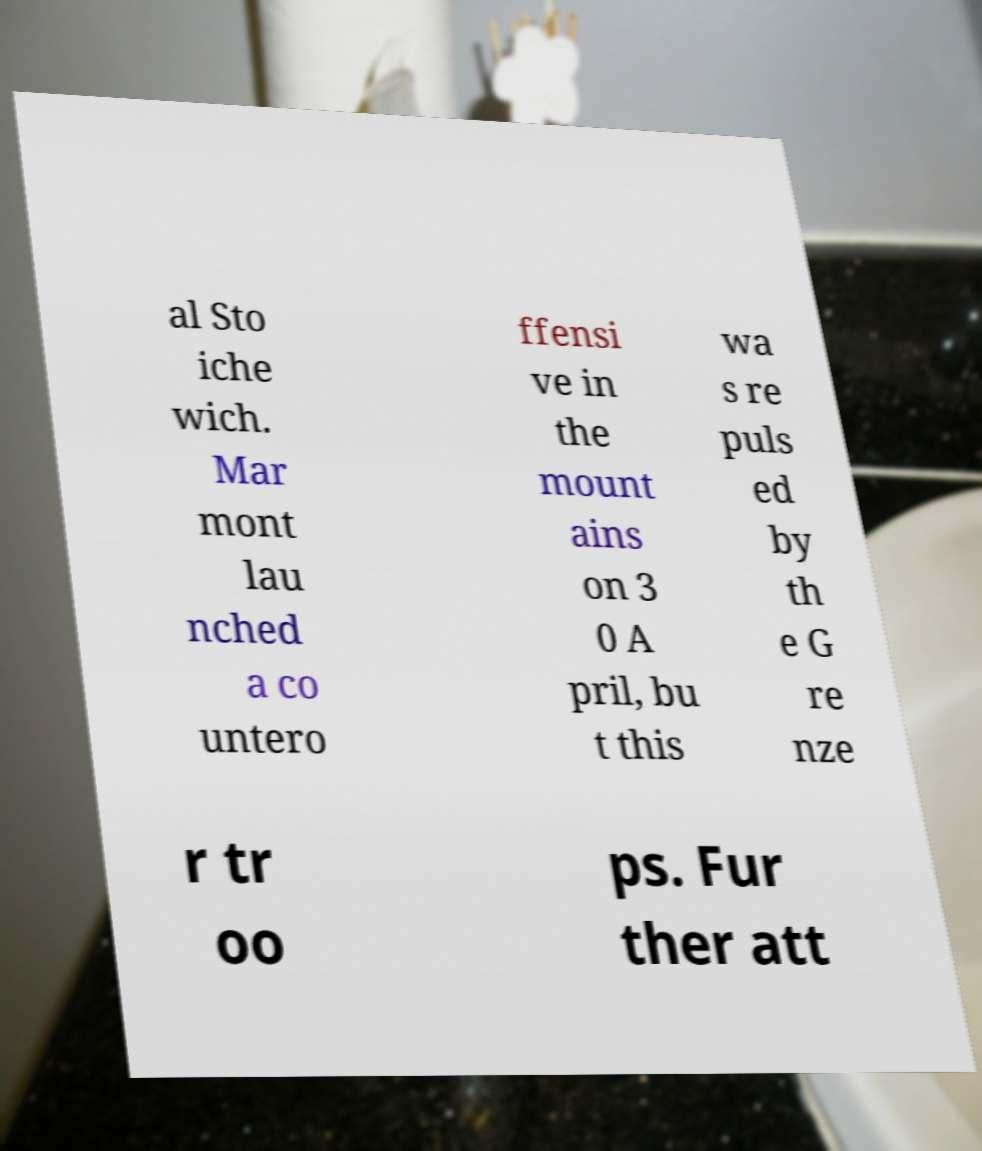Please identify and transcribe the text found in this image. al Sto iche wich. Mar mont lau nched a co untero ffensi ve in the mount ains on 3 0 A pril, bu t this wa s re puls ed by th e G re nze r tr oo ps. Fur ther att 